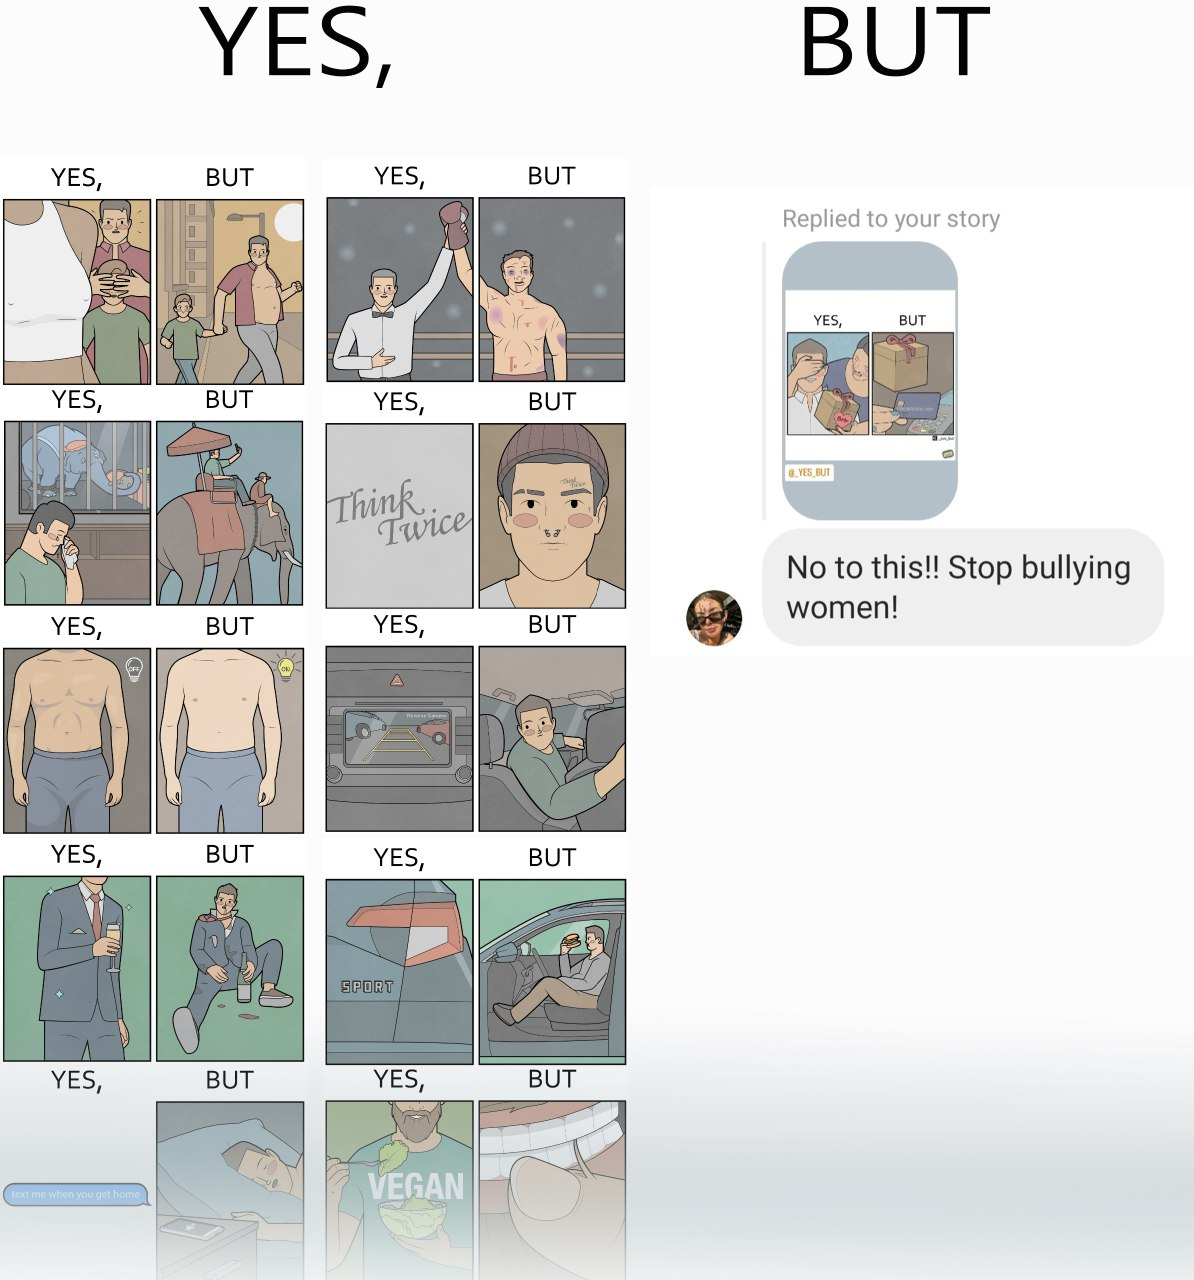Does this image contain satire or humor? Yes, this image is satirical. 